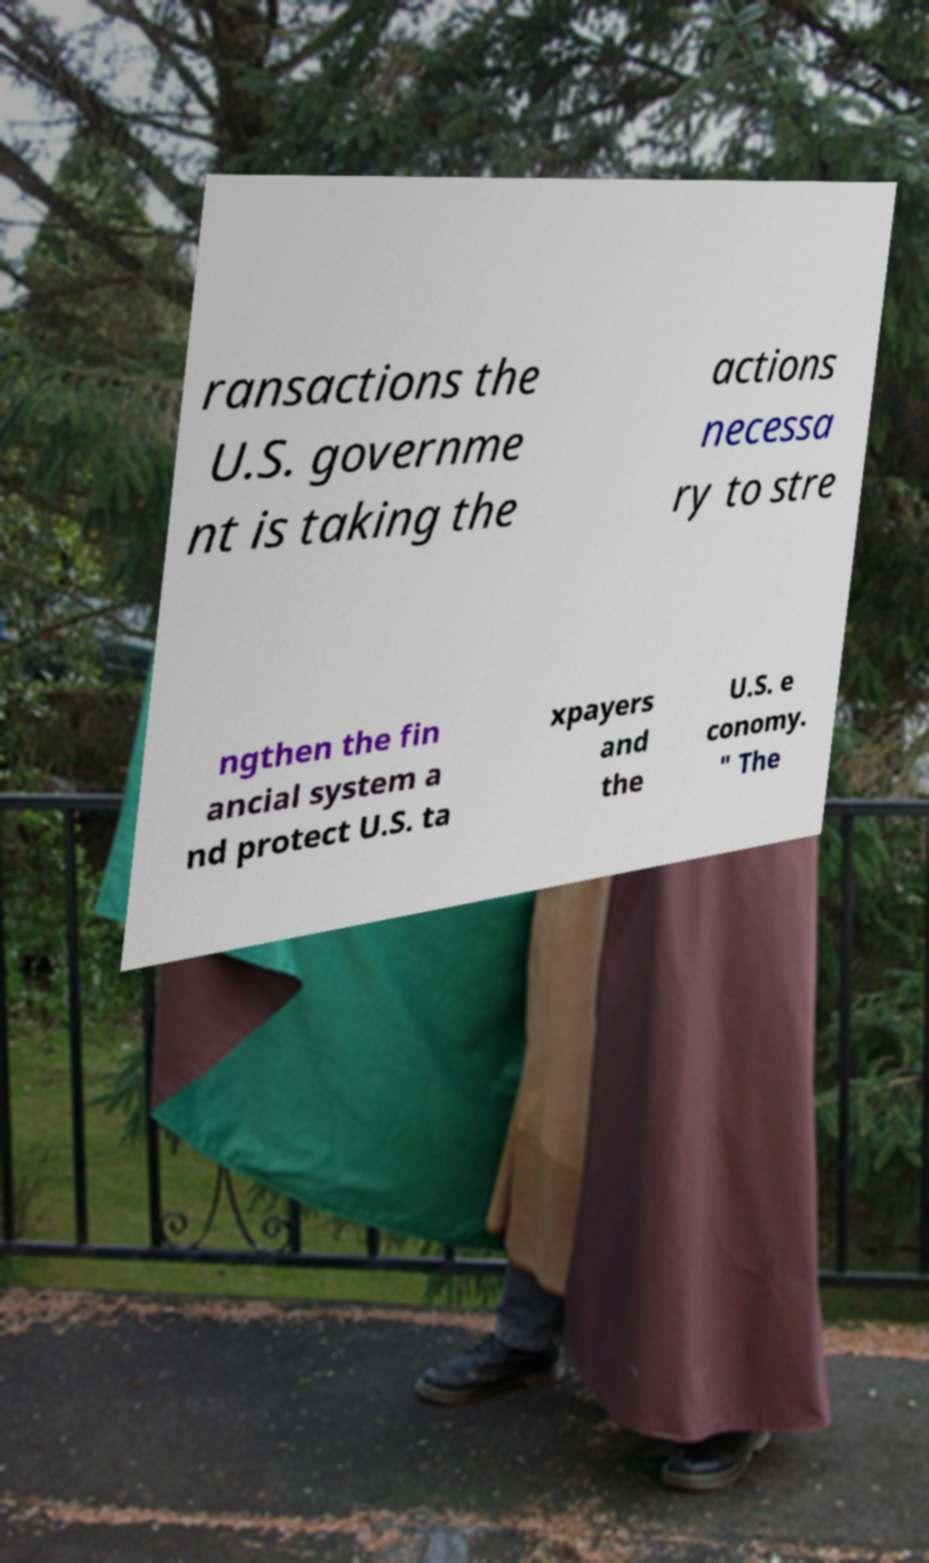Can you read and provide the text displayed in the image?This photo seems to have some interesting text. Can you extract and type it out for me? ransactions the U.S. governme nt is taking the actions necessa ry to stre ngthen the fin ancial system a nd protect U.S. ta xpayers and the U.S. e conomy. " The 